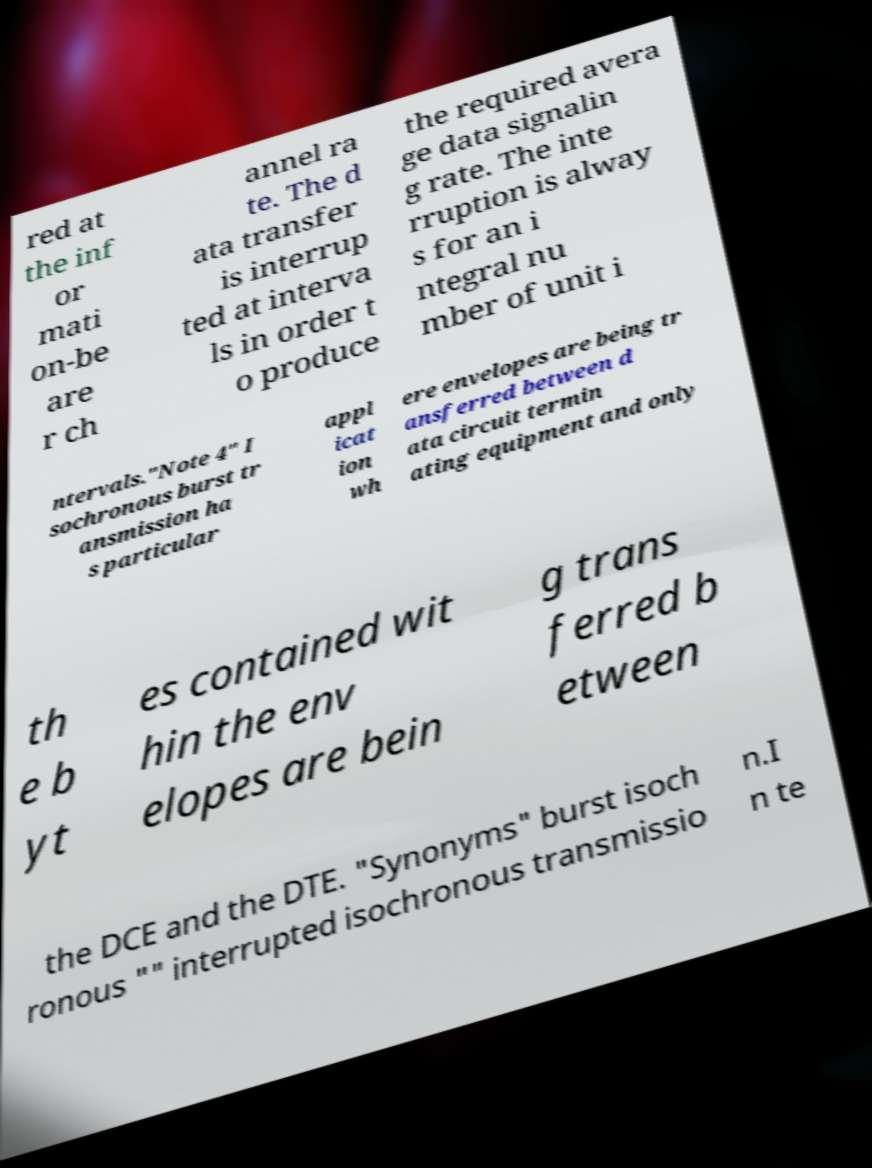Can you read and provide the text displayed in the image?This photo seems to have some interesting text. Can you extract and type it out for me? red at the inf or mati on-be are r ch annel ra te. The d ata transfer is interrup ted at interva ls in order t o produce the required avera ge data signalin g rate. The inte rruption is alway s for an i ntegral nu mber of unit i ntervals."Note 4" I sochronous burst tr ansmission ha s particular appl icat ion wh ere envelopes are being tr ansferred between d ata circuit termin ating equipment and only th e b yt es contained wit hin the env elopes are bein g trans ferred b etween the DCE and the DTE. "Synonyms" burst isoch ronous "" interrupted isochronous transmissio n.I n te 